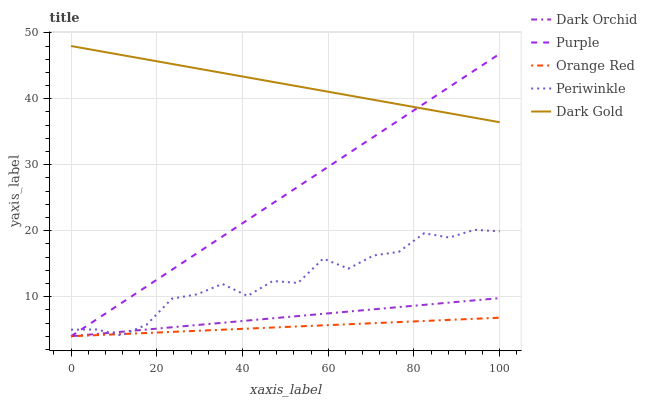Does Orange Red have the minimum area under the curve?
Answer yes or no. Yes. Does Dark Gold have the maximum area under the curve?
Answer yes or no. Yes. Does Periwinkle have the minimum area under the curve?
Answer yes or no. No. Does Periwinkle have the maximum area under the curve?
Answer yes or no. No. Is Orange Red the smoothest?
Answer yes or no. Yes. Is Periwinkle the roughest?
Answer yes or no. Yes. Is Periwinkle the smoothest?
Answer yes or no. No. Is Orange Red the roughest?
Answer yes or no. No. Does Purple have the lowest value?
Answer yes or no. Yes. Does Periwinkle have the lowest value?
Answer yes or no. No. Does Dark Gold have the highest value?
Answer yes or no. Yes. Does Periwinkle have the highest value?
Answer yes or no. No. Is Periwinkle less than Dark Gold?
Answer yes or no. Yes. Is Dark Gold greater than Dark Orchid?
Answer yes or no. Yes. Does Dark Orchid intersect Purple?
Answer yes or no. Yes. Is Dark Orchid less than Purple?
Answer yes or no. No. Is Dark Orchid greater than Purple?
Answer yes or no. No. Does Periwinkle intersect Dark Gold?
Answer yes or no. No. 